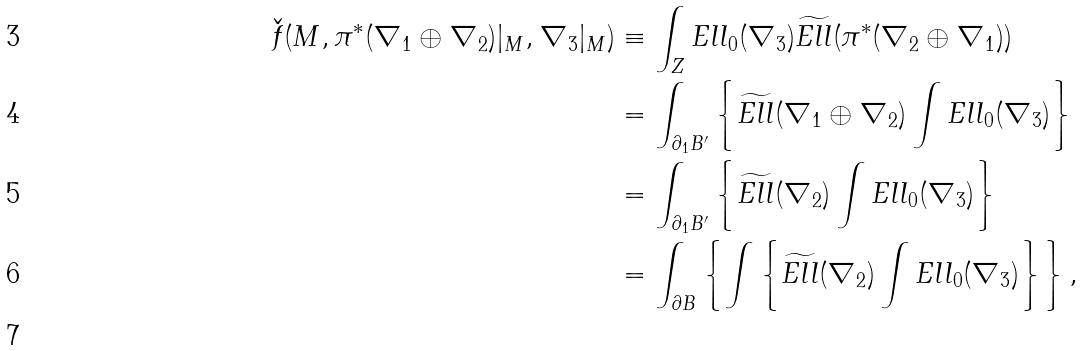<formula> <loc_0><loc_0><loc_500><loc_500>\check { f } ( M , \pi ^ { * } ( \nabla _ { 1 } \oplus \nabla _ { 2 } ) | _ { M } , \nabla _ { 3 } | _ { M } ) & \equiv \int _ { Z } E l l _ { 0 } ( \nabla _ { 3 } ) \widetilde { E l l } ( \pi ^ { * } ( \nabla _ { 2 } \oplus \nabla _ { 1 } ) ) \\ & = \int _ { \partial _ { 1 } B ^ { \prime } } \left \{ \widetilde { E l l } ( \nabla _ { 1 } \oplus \nabla _ { 2 } ) \int E l l _ { 0 } ( \nabla _ { 3 } ) \right \} \\ & = \int _ { \partial _ { 1 } B ^ { \prime } } \left \{ \widetilde { E l l } ( \nabla _ { 2 } ) \int E l l _ { 0 } ( \nabla _ { 3 } ) \right \} \\ & = \int _ { \partial B } \left \{ \int \left \{ \widetilde { E l l } ( \nabla _ { 2 } ) \int E l l _ { 0 } ( \nabla _ { 3 } ) \right \} \right \} , \\</formula> 